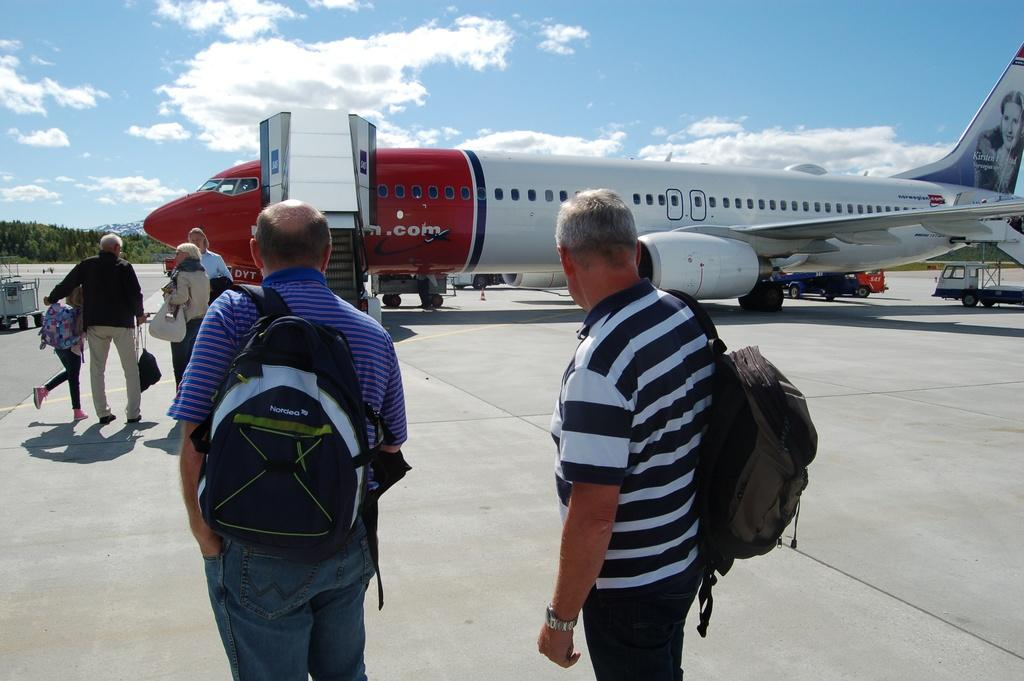<image>
Relay a brief, clear account of the picture shown. Some travelers mill about outside of a Norwegian Airlines plane parked on the tarmac. 